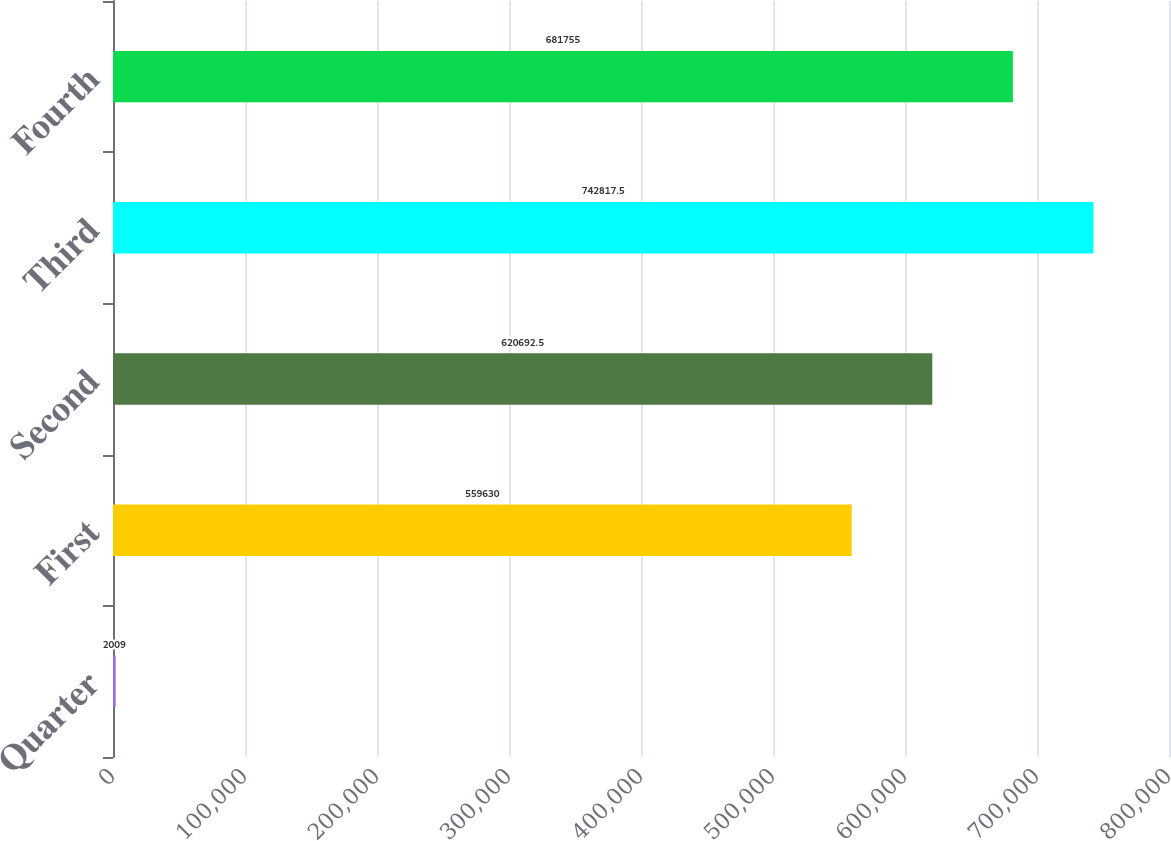Convert chart to OTSL. <chart><loc_0><loc_0><loc_500><loc_500><bar_chart><fcel>Quarter<fcel>First<fcel>Second<fcel>Third<fcel>Fourth<nl><fcel>2009<fcel>559630<fcel>620692<fcel>742818<fcel>681755<nl></chart> 